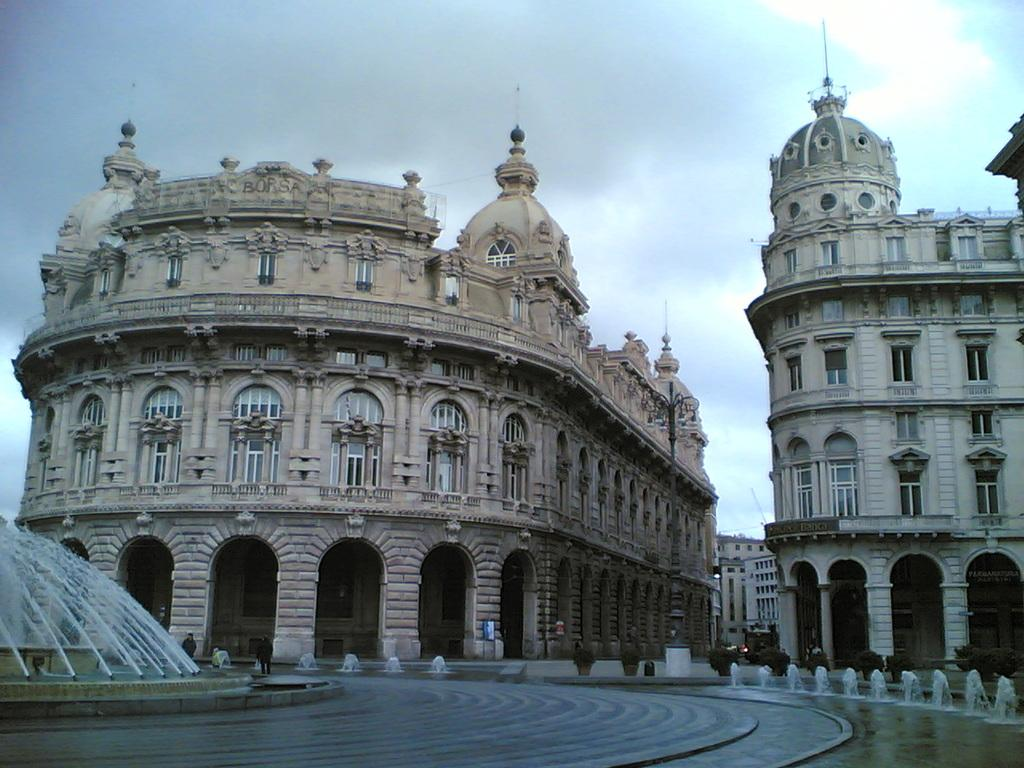What is the main feature in the image? There is a water fountain in the image. What else can be seen in the image besides the water fountain? There are buildings, plants, and boards visible in the image. What is visible in the background of the image? The sky is visible in the background of the image. What type of error can be seen in the image? There is no error present in the image; it is a clear depiction of a water fountain, buildings, plants, boards, and the sky. 